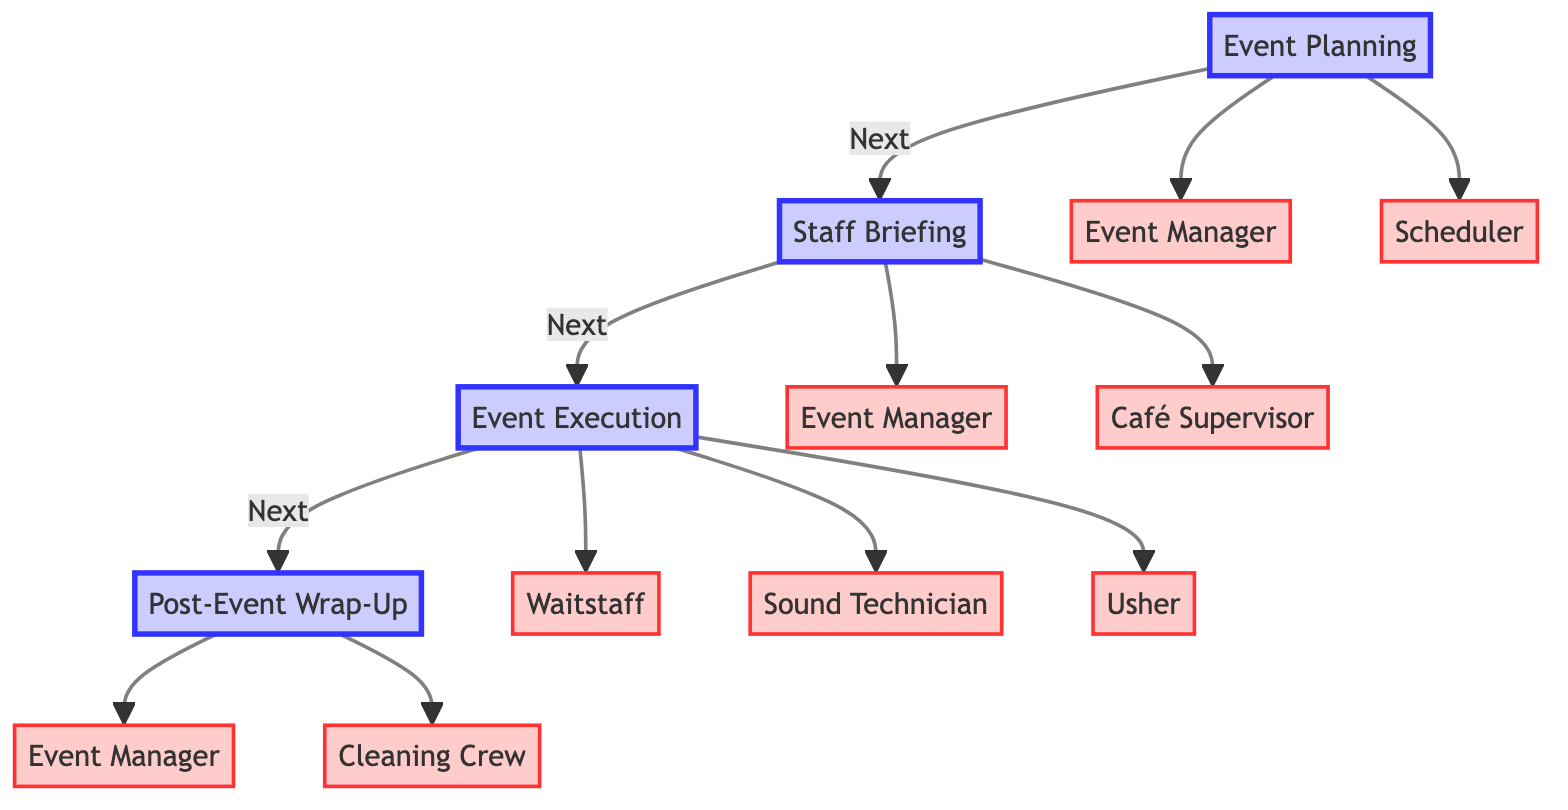What are the first two steps in the event process? The first two steps in the diagram are "Event Planning" and "Staff Briefing". These are listed sequentially at the top of the diagram, indicating the order of the events.
Answer: Event Planning, Staff Briefing How many roles are assigned to the "Event Execution" step? The "Event Execution" step has three assigned roles: "Waitstaff", "Sound Technician", and "Usher". This can be confirmed by counting the individual roles listed under this event step in the diagram.
Answer: 3 Who conducts the debriefing session after the event? The role responsible for conducting the debriefing session is the "Event Manager", as indicated under the "Post-Event Wrap-Up" step in the diagram.
Answer: Event Manager Which role is responsible for assigning shifts to staff? The "Scheduler" role is responsible for assigning shifts to staff, as seen under the "Event Planning" step. This role outlines the responsibility directly in the diagram.
Answer: Scheduler What is the last step in the event process? The last step in the event process is "Post-Event Wrap-Up". This is visually depicted as the final node in the progression of event steps in the diagram.
Answer: Post-Event Wrap-Up How many responsibilities does the "Café Supervisor" have? The "Café Supervisor" has two responsibilities listed: "Update staff on special menu items" and "Provide guidelines for guest interactions". This can be easily counted from the bullet points listed under this role.
Answer: 2 What is the main role of the "Sound Technician"? The main responsibilities of the "Sound Technician" include "Manage audio setup" and "Ensure optimal sound quality", as outlined under the "Event Execution" step.
Answer: Manage audio setup, Ensure optimal sound quality Which role is involved in the cleaning process after the event? The "Cleaning Crew" is involved in the cleaning process, as it is specifically listed under the "Post-Event Wrap-Up" step in the diagram.
Answer: Cleaning Crew What role is responsible for providing programs and event details? The "Usher" is responsible for providing programs and event details during the "Event Execution" step, as explicitly mentioned under their responsibilities.
Answer: Usher 